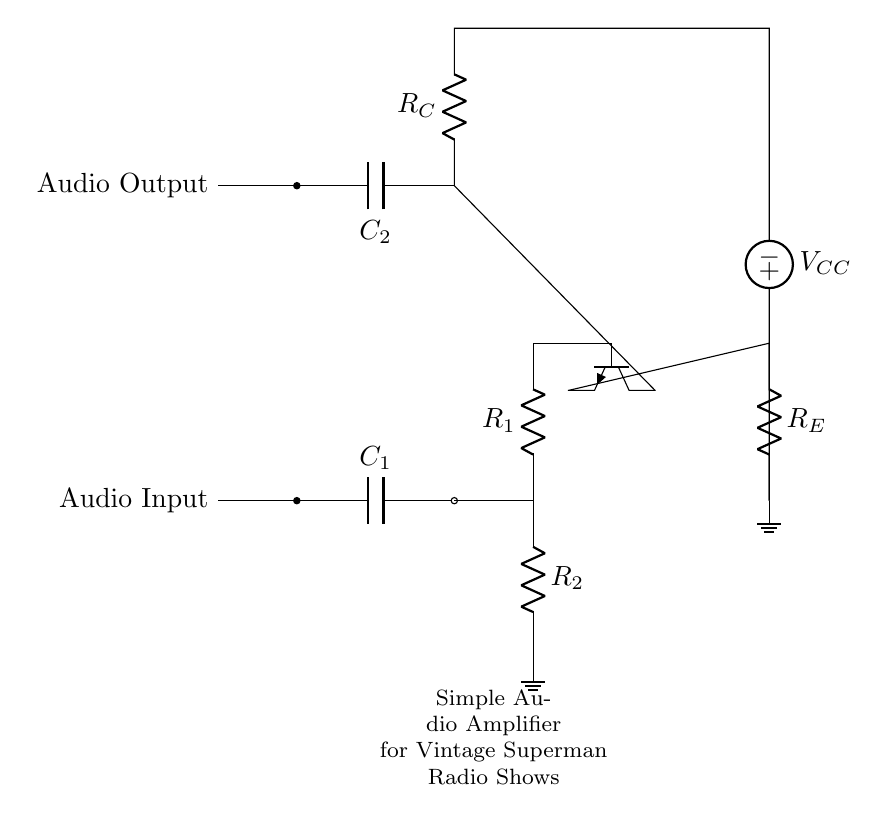What is the type of amplifier shown in the circuit? The circuit contains a transistor, specifically an NPN type, which is typically used for amplification.
Answer: NPN amplifier What is the purpose of capacitor one labeled C1? Capacitor C1 serves as a coupling capacitor, allowing the AC audio signal to pass while blocking any DC component present at the input.
Answer: Coupling What is the function of resistor R1? Resistor R1 is part of the biasing network for the transistor, establishing the proper operating point for the transistor to amplify signals effectively.
Answer: Biasing What does the symbol next to R_E represent? The symbol is a ground connection, indicating that the emitter resistor R_E is connected to the circuit's ground reference.
Answer: Ground Calculate the total current if V_CC is 10 volts and R_C is 1k ohms. Using Ohm's law (I = V/R), the total current can be calculated from the voltage across R_C, which is equal to V_CC. I = 10V / 1000Ω = 0.01A or 10mA.
Answer: 10mA What is the gain operation mode of the amplifier? The amplifier operates in the active mode, where the transistor is biased correctly to allow signal amplification without saturation or cutoff.
Answer: Active What is the output type of the circuit? The output is an audio output, which is the amplified audio signal produced at the output junction of the circuit.
Answer: Audio output 